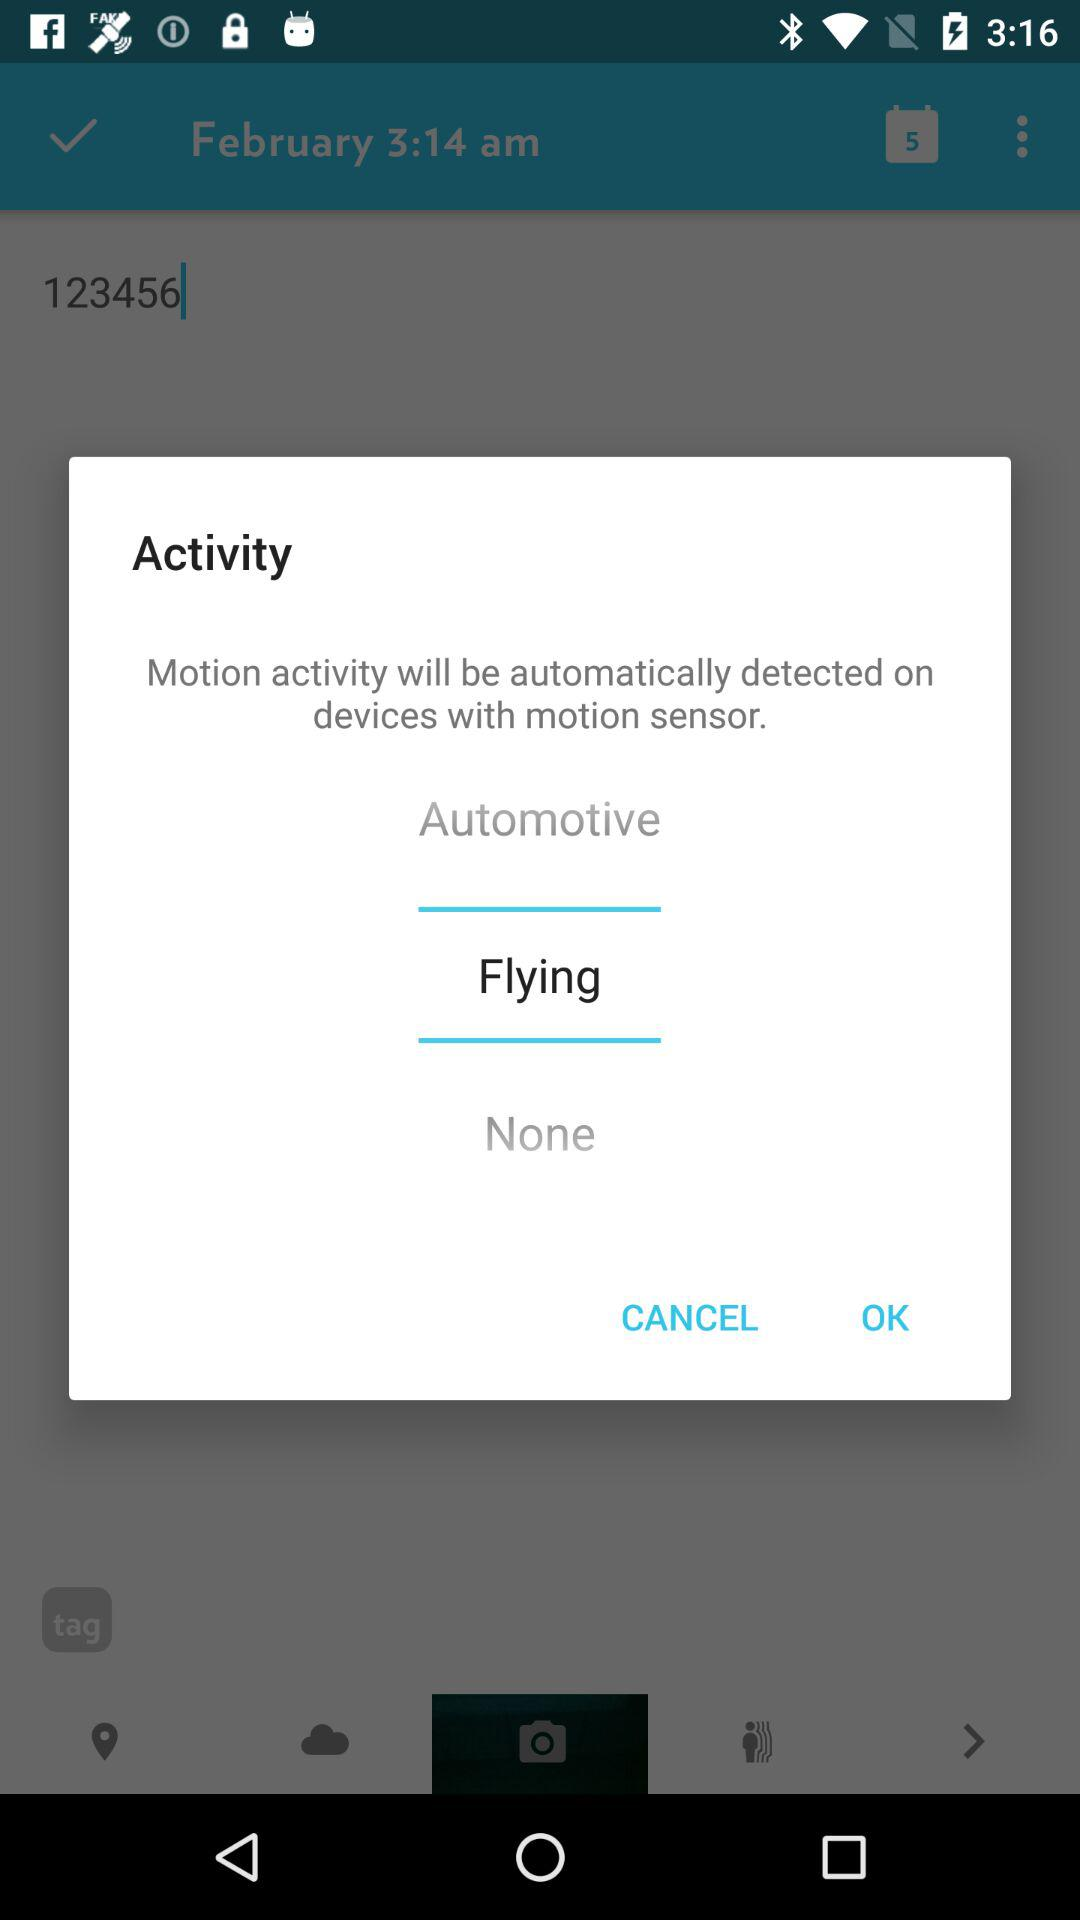When does the automatic motion detector time out?
When the provided information is insufficient, respond with <no answer>. <no answer> 